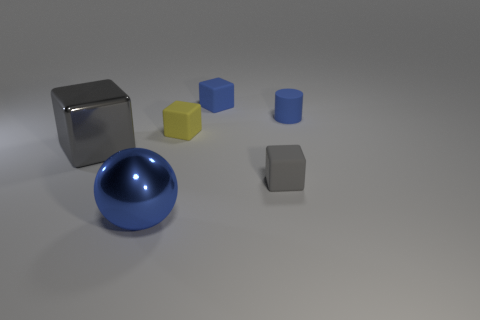There is a large blue metal object; is it the same shape as the small blue object that is left of the small gray block?
Ensure brevity in your answer.  No. What is the shape of the big blue object?
Offer a terse response. Sphere. What is the material of the gray thing that is the same size as the sphere?
Your answer should be compact. Metal. Is there anything else that has the same size as the blue rubber block?
Your answer should be compact. Yes. How many objects are either tiny blue rubber things or metal things behind the big metallic sphere?
Give a very brief answer. 3. The gray thing that is made of the same material as the tiny yellow thing is what size?
Offer a very short reply. Small. The small blue matte object that is to the right of the small rubber cube that is behind the tiny yellow object is what shape?
Make the answer very short. Cylinder. There is a thing that is on the left side of the small yellow cube and behind the blue sphere; how big is it?
Your answer should be compact. Large. Is there a big red object of the same shape as the large blue thing?
Provide a succinct answer. No. Is there any other thing that has the same shape as the large gray object?
Offer a terse response. Yes. 